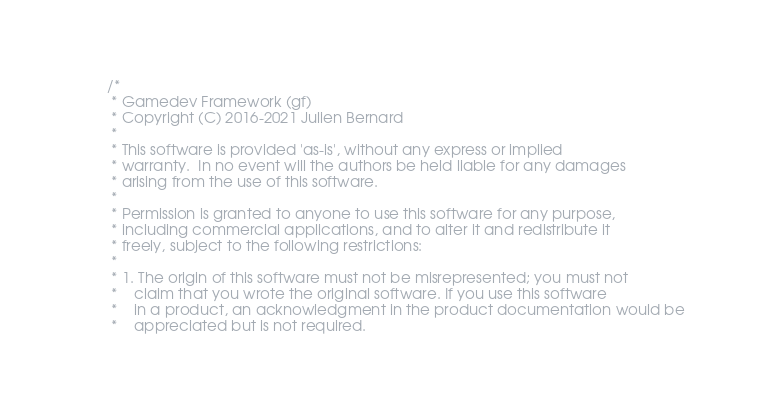<code> <loc_0><loc_0><loc_500><loc_500><_C_>/*
 * Gamedev Framework (gf)
 * Copyright (C) 2016-2021 Julien Bernard
 *
 * This software is provided 'as-is', without any express or implied
 * warranty.  In no event will the authors be held liable for any damages
 * arising from the use of this software.
 *
 * Permission is granted to anyone to use this software for any purpose,
 * including commercial applications, and to alter it and redistribute it
 * freely, subject to the following restrictions:
 *
 * 1. The origin of this software must not be misrepresented; you must not
 *    claim that you wrote the original software. If you use this software
 *    in a product, an acknowledgment in the product documentation would be
 *    appreciated but is not required.</code> 